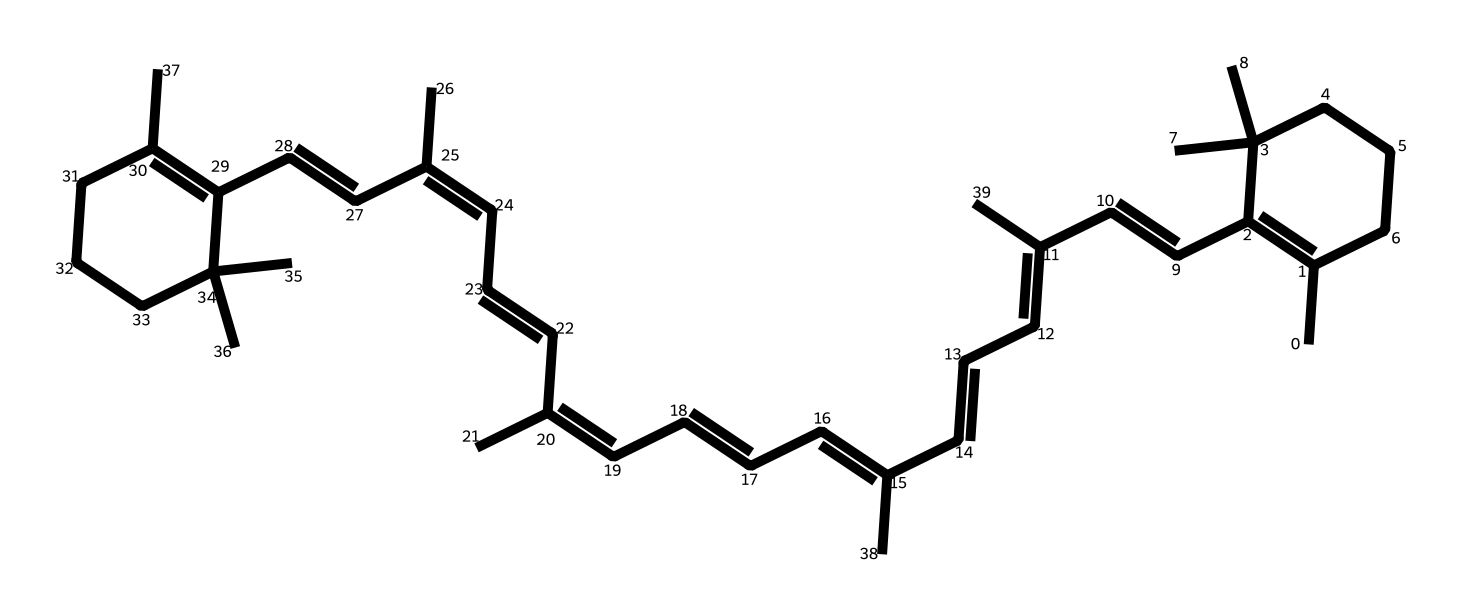how many rings are present in the chemical structure? By analyzing the SMILES representation, I see that there are two cyclohexane rings indicated by the "C1" and "C2" labels, representing the starting and ending points of each ring structure.
Answer: two what is the degree of unsaturation in this chemical? The degree of unsaturation can be determined by counting the number of double bonds and rings. The presence of multiple double bonds suggests several degrees of unsaturation, and by inspection of the structure, I estimate around 6 double bonds and 2 rings, leading to a total of 8 degrees of unsaturation.
Answer: eight what type of chemical structure is represented? This chemical is categorized as a carotenoid, characterized by a long chain of conjugated double bonds and a specific arrangement of carbon atoms that allow for antioxidant properties.
Answer: carotenoid what is the maximum number of hydrogen atoms this molecule could have? To find the maximum number of hydrogen atoms, the general formula for a fully saturated hydrocarbon (C_nH_(2n+2)) applies. Given the carbon count derived from the structure (which I can count as 40), the maximum would be H_(2*40+2) = 82. However, due to double bonds and rings, actual hydrogen count will be lower.
Answer: eighty-two how many carbon atoms are present in the chemical structure? By examining the SMILES and counting the carbon (C) notations, I find there are a total of 40 carbon atoms represented in the structure.
Answer: forty which part of the chemical contributes to its antioxidant properties? The presence of conjugated double bonds contributes significantly to the antioxidant properties of carotenoids. These double bonds allow for the delocalization of electrons, which is a key factor in scavenging free radicals.
Answer: conjugated double bonds 